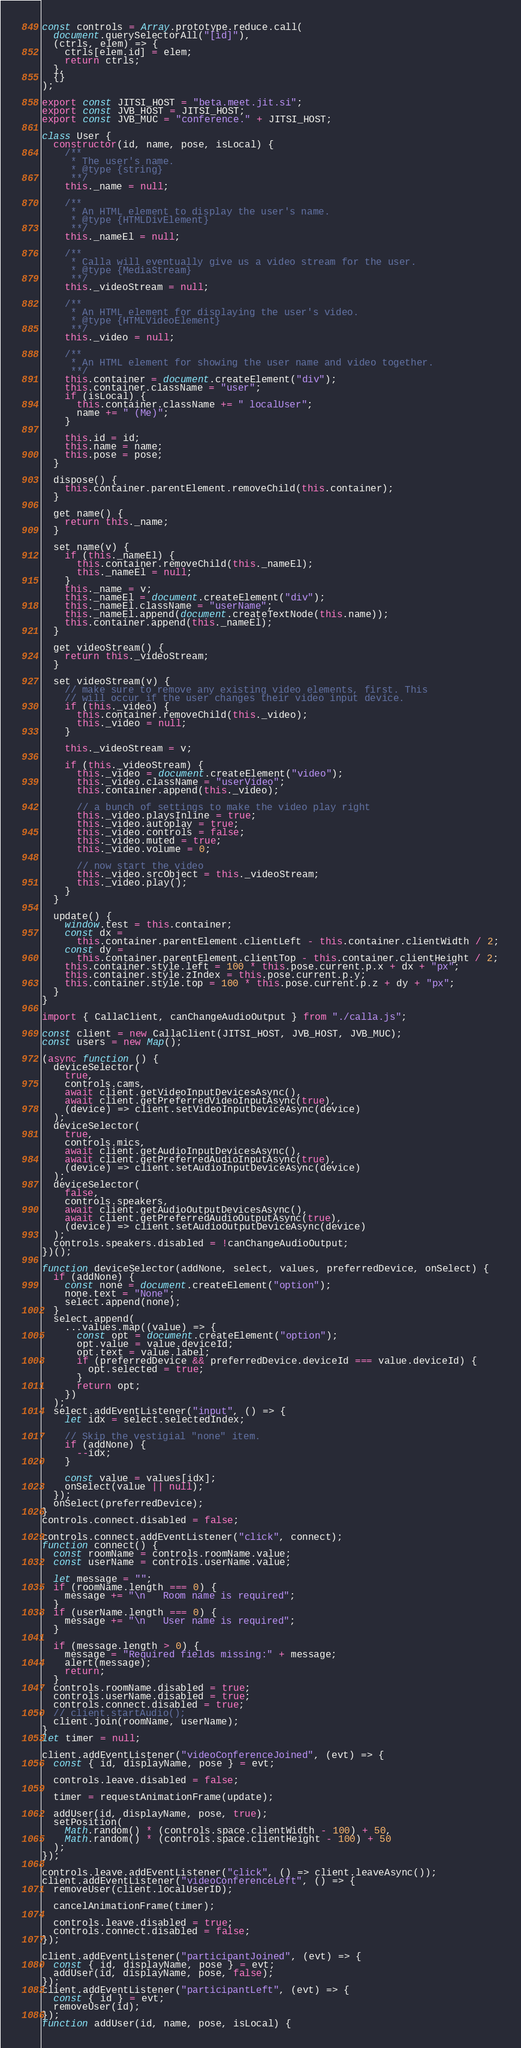Convert code to text. <code><loc_0><loc_0><loc_500><loc_500><_JavaScript_>const controls = Array.prototype.reduce.call(
  document.querySelectorAll("[id]"),
  (ctrls, elem) => {
    ctrls[elem.id] = elem;
    return ctrls;
  },
  {}
);

export const JITSI_HOST = "beta.meet.jit.si";
export const JVB_HOST = JITSI_HOST;
export const JVB_MUC = "conference." + JITSI_HOST;

class User {
  constructor(id, name, pose, isLocal) {
    /**
     * The user's name.
     * @type {string}
     **/
    this._name = null;

    /**
     * An HTML element to display the user's name.
     * @type {HTMLDivElement}
     **/
    this._nameEl = null;

    /**
     * Calla will eventually give us a video stream for the user.
     * @type {MediaStream}
     **/
    this._videoStream = null;

    /**
     * An HTML element for displaying the user's video.
     * @type {HTMLVideoElement}
     **/
    this._video = null;

    /**
     * An HTML element for showing the user name and video together.
     **/
    this.container = document.createElement("div");
    this.container.className = "user";
    if (isLocal) {
      this.container.className += " localUser";
      name += " (Me)";
    }

    this.id = id;
    this.name = name;
    this.pose = pose;
  }

  dispose() {
    this.container.parentElement.removeChild(this.container);
  }

  get name() {
    return this._name;
  }

  set name(v) {
    if (this._nameEl) {
      this.container.removeChild(this._nameEl);
      this._nameEl = null;
    }
    this._name = v;
    this._nameEl = document.createElement("div");
    this._nameEl.className = "userName";
    this._nameEl.append(document.createTextNode(this.name));
    this.container.append(this._nameEl);
  }

  get videoStream() {
    return this._videoStream;
  }

  set videoStream(v) {
    // make sure to remove any existing video elements, first. This
    // will occur if the user changes their video input device.
    if (this._video) {
      this.container.removeChild(this._video);
      this._video = null;
    }

    this._videoStream = v;

    if (this._videoStream) {
      this._video = document.createElement("video");
      this._video.className = "userVideo";
      this.container.append(this._video);

      // a bunch of settings to make the video play right
      this._video.playsInline = true;
      this._video.autoplay = true;
      this._video.controls = false;
      this._video.muted = true;
      this._video.volume = 0;

      // now start the video
      this._video.srcObject = this._videoStream;
      this._video.play();
    }
  }

  update() {
    window.test = this.container;
    const dx =
      this.container.parentElement.clientLeft - this.container.clientWidth / 2;
    const dy =
      this.container.parentElement.clientTop - this.container.clientHeight / 2;
    this.container.style.left = 100 * this.pose.current.p.x + dx + "px";
    this.container.style.zIndex = this.pose.current.p.y;
    this.container.style.top = 100 * this.pose.current.p.z + dy + "px";
  }
}

import { CallaClient, canChangeAudioOutput } from "./calla.js";

const client = new CallaClient(JITSI_HOST, JVB_HOST, JVB_MUC);
const users = new Map();

(async function () {
  deviceSelector(
    true,
    controls.cams,
    await client.getVideoInputDevicesAsync(),
    await client.getPreferredVideoInputAsync(true),
    (device) => client.setVideoInputDeviceAsync(device)
  );
  deviceSelector(
    true,
    controls.mics,
    await client.getAudioInputDevicesAsync(),
    await client.getPreferredAudioInputAsync(true),
    (device) => client.setAudioInputDeviceAsync(device)
  );
  deviceSelector(
    false,
    controls.speakers,
    await client.getAudioOutputDevicesAsync(),
    await client.getPreferredAudioOutputAsync(true),
    (device) => client.setAudioOutputDeviceAsync(device)
  );
  controls.speakers.disabled = !canChangeAudioOutput;
})();

function deviceSelector(addNone, select, values, preferredDevice, onSelect) {
  if (addNone) {
    const none = document.createElement("option");
    none.text = "None";
    select.append(none);
  }
  select.append(
    ...values.map((value) => {
      const opt = document.createElement("option");
      opt.value = value.deviceId;
      opt.text = value.label;
      if (preferredDevice && preferredDevice.deviceId === value.deviceId) {
        opt.selected = true;
      }
      return opt;
    })
  );
  select.addEventListener("input", () => {
    let idx = select.selectedIndex;

    // Skip the vestigial "none" item.
    if (addNone) {
      --idx;
    }

    const value = values[idx];
    onSelect(value || null);
  });
  onSelect(preferredDevice);
}
controls.connect.disabled = false;

controls.connect.addEventListener("click", connect);
function connect() {
  const roomName = controls.roomName.value;
  const userName = controls.userName.value;

  let message = "";
  if (roomName.length === 0) {
    message += "\n   Room name is required";
  }
  if (userName.length === 0) {
    message += "\n   User name is required";
  }

  if (message.length > 0) {
    message = "Required fields missing:" + message;
    alert(message);
    return;
  }
  controls.roomName.disabled = true;
  controls.userName.disabled = true;
  controls.connect.disabled = true;
  // client.startAudio();
  client.join(roomName, userName);
}
let timer = null;

client.addEventListener("videoConferenceJoined", (evt) => {
  const { id, displayName, pose } = evt;

  controls.leave.disabled = false;

  timer = requestAnimationFrame(update);

  addUser(id, displayName, pose, true);
  setPosition(
    Math.random() * (controls.space.clientWidth - 100) + 50,
    Math.random() * (controls.space.clientHeight - 100) + 50
  );
});

controls.leave.addEventListener("click", () => client.leaveAsync());
client.addEventListener("videoConferenceLeft", () => {
  removeUser(client.localUserID);

  cancelAnimationFrame(timer);

  controls.leave.disabled = true;
  controls.connect.disabled = false;
});

client.addEventListener("participantJoined", (evt) => {
  const { id, displayName, pose } = evt;
  addUser(id, displayName, pose, false);
});
client.addEventListener("participantLeft", (evt) => {
  const { id } = evt;
  removeUser(id);
});
function addUser(id, name, pose, isLocal) {</code> 